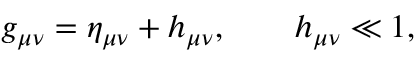<formula> <loc_0><loc_0><loc_500><loc_500>g _ { \mu \nu } = \eta _ { \mu \nu } + h _ { \mu \nu } , \quad h _ { \mu \nu } \ll 1 ,</formula> 